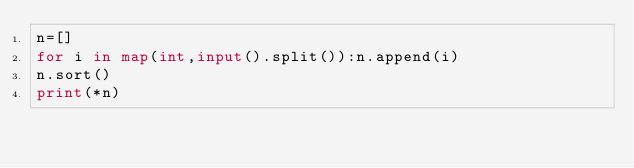<code> <loc_0><loc_0><loc_500><loc_500><_Python_>n=[]
for i in map(int,input().split()):n.append(i)
n.sort()
print(*n)
</code> 